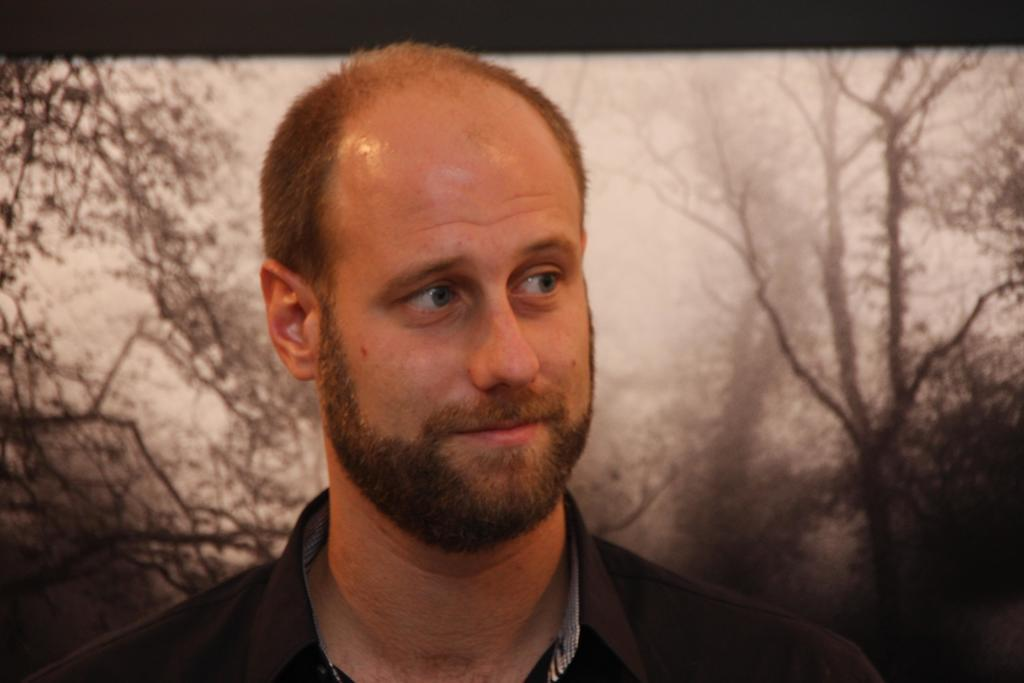What is the main subject of the image? There is a person standing in the image. What can be seen in the background of the image? There appears to be a screen and trees visible in the background of the image. How many tins are stacked on the person's head in the image? There are no tins present in the image; the person is not holding or wearing any tins. What is the cause of death for the person in the image? There is no indication of death in the image, as the person is standing and appears to be alive. 